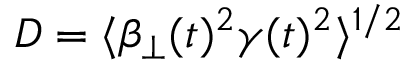<formula> <loc_0><loc_0><loc_500><loc_500>D = \langle \beta _ { \perp } ( t ) ^ { 2 } \gamma ( t ) ^ { 2 } \rangle ^ { 1 / 2 }</formula> 